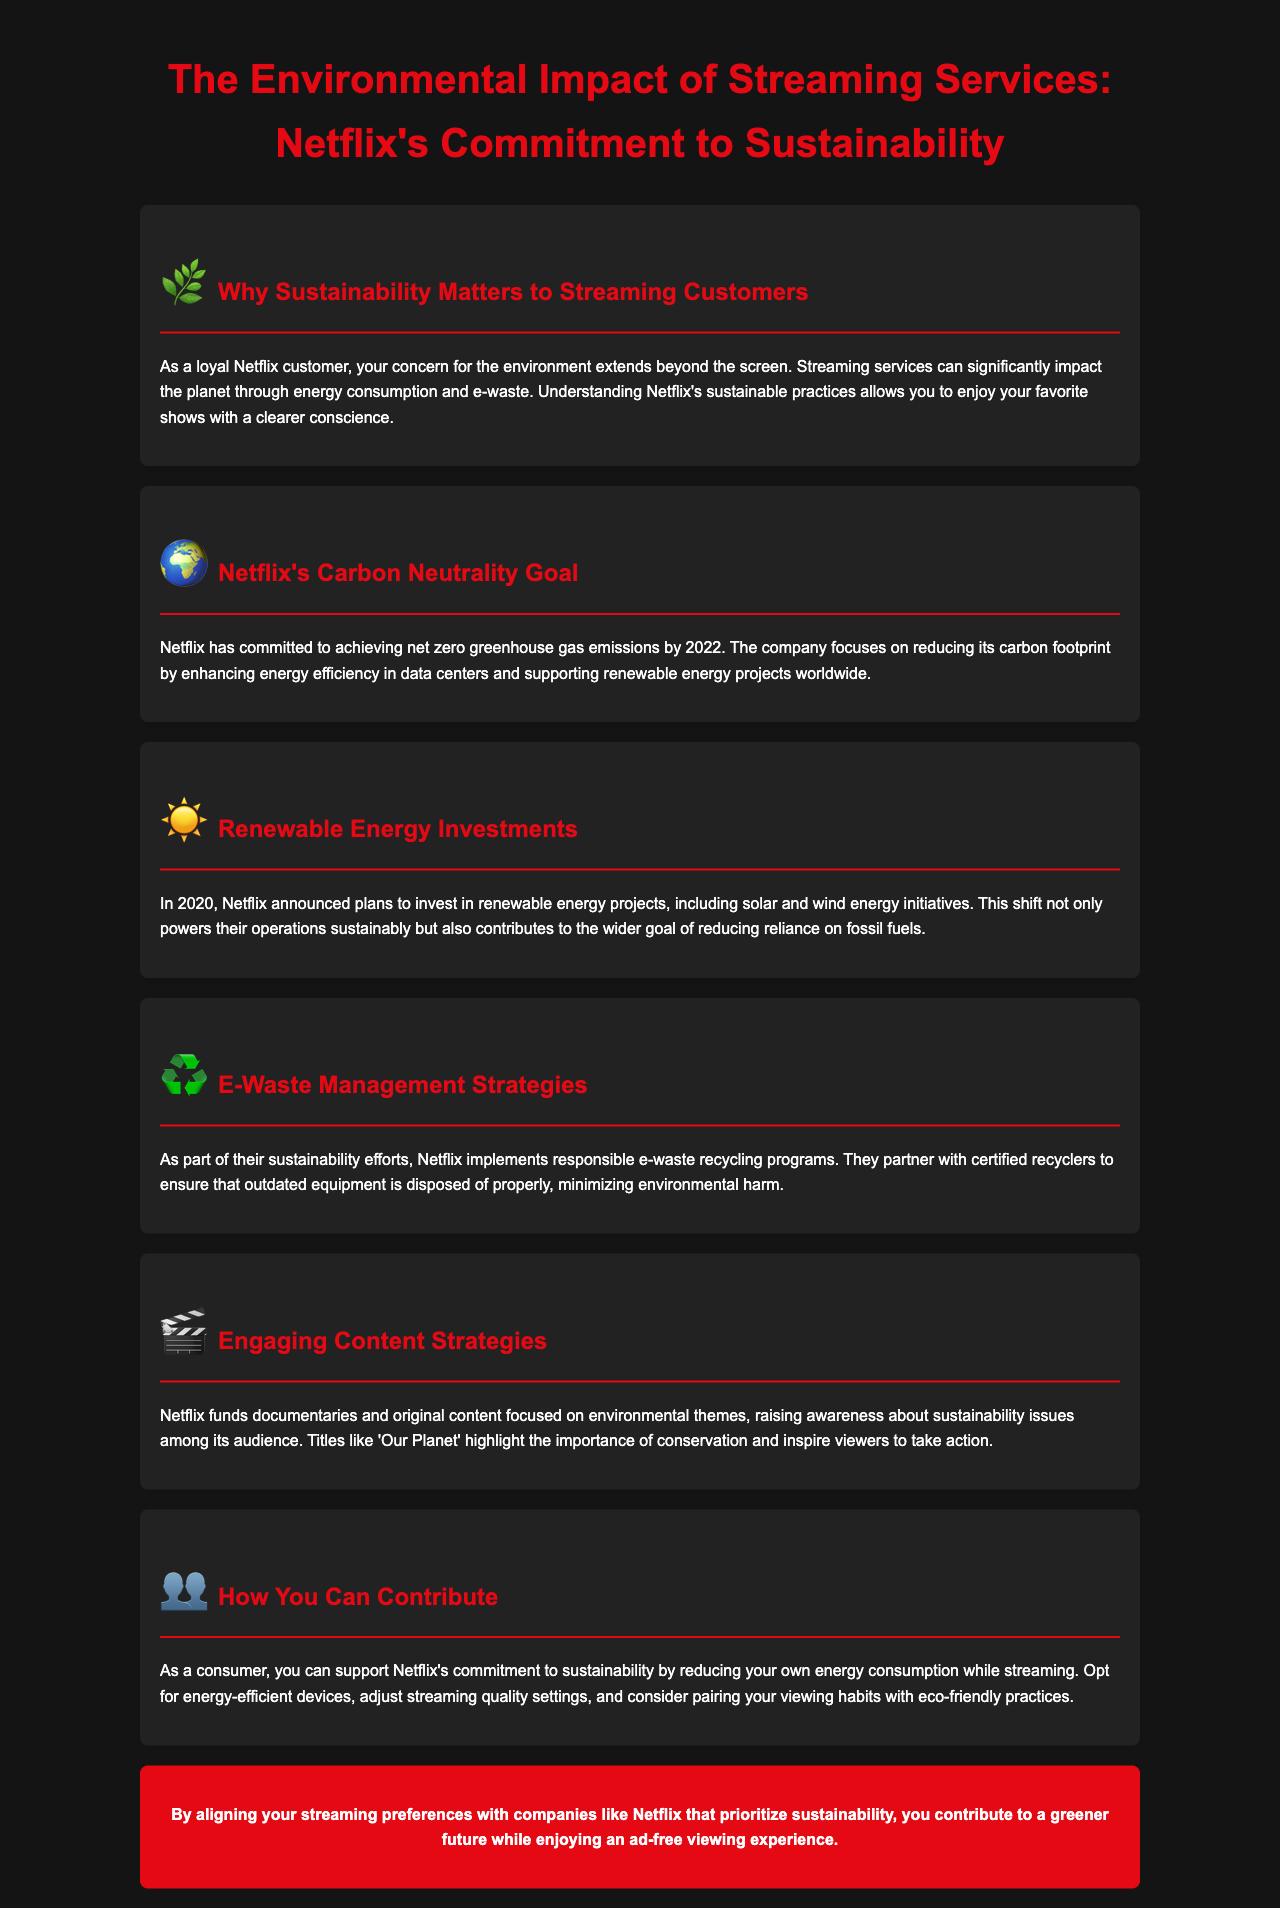What is Netflix's carbon neutrality goal? The document states that Netflix has committed to achieving net zero greenhouse gas emissions by 2022.
Answer: net zero greenhouse gas emissions by 2022 What types of renewable energy is Netflix investing in? The document mentions that Netflix is investing in solar and wind energy initiatives.
Answer: solar and wind energy What are Netflix's strategies for e-waste management? The document describes that Netflix implements responsible e-waste recycling programs and partners with certified recyclers.
Answer: responsible e-waste recycling programs Which documentary is mentioned in relation to environmental themes? The document references the title 'Our Planet' as an example of content highlighting conservation.
Answer: Our Planet How can consumers contribute to Netflix's sustainability efforts? The document advises consumers to reduce their energy consumption while streaming and consider eco-friendly practices.
Answer: reduce energy consumption Why is sustainability important to streaming customers? The document explains that streaming services significantly impact the planet through energy consumption and e-waste.
Answer: energy consumption and e-waste 